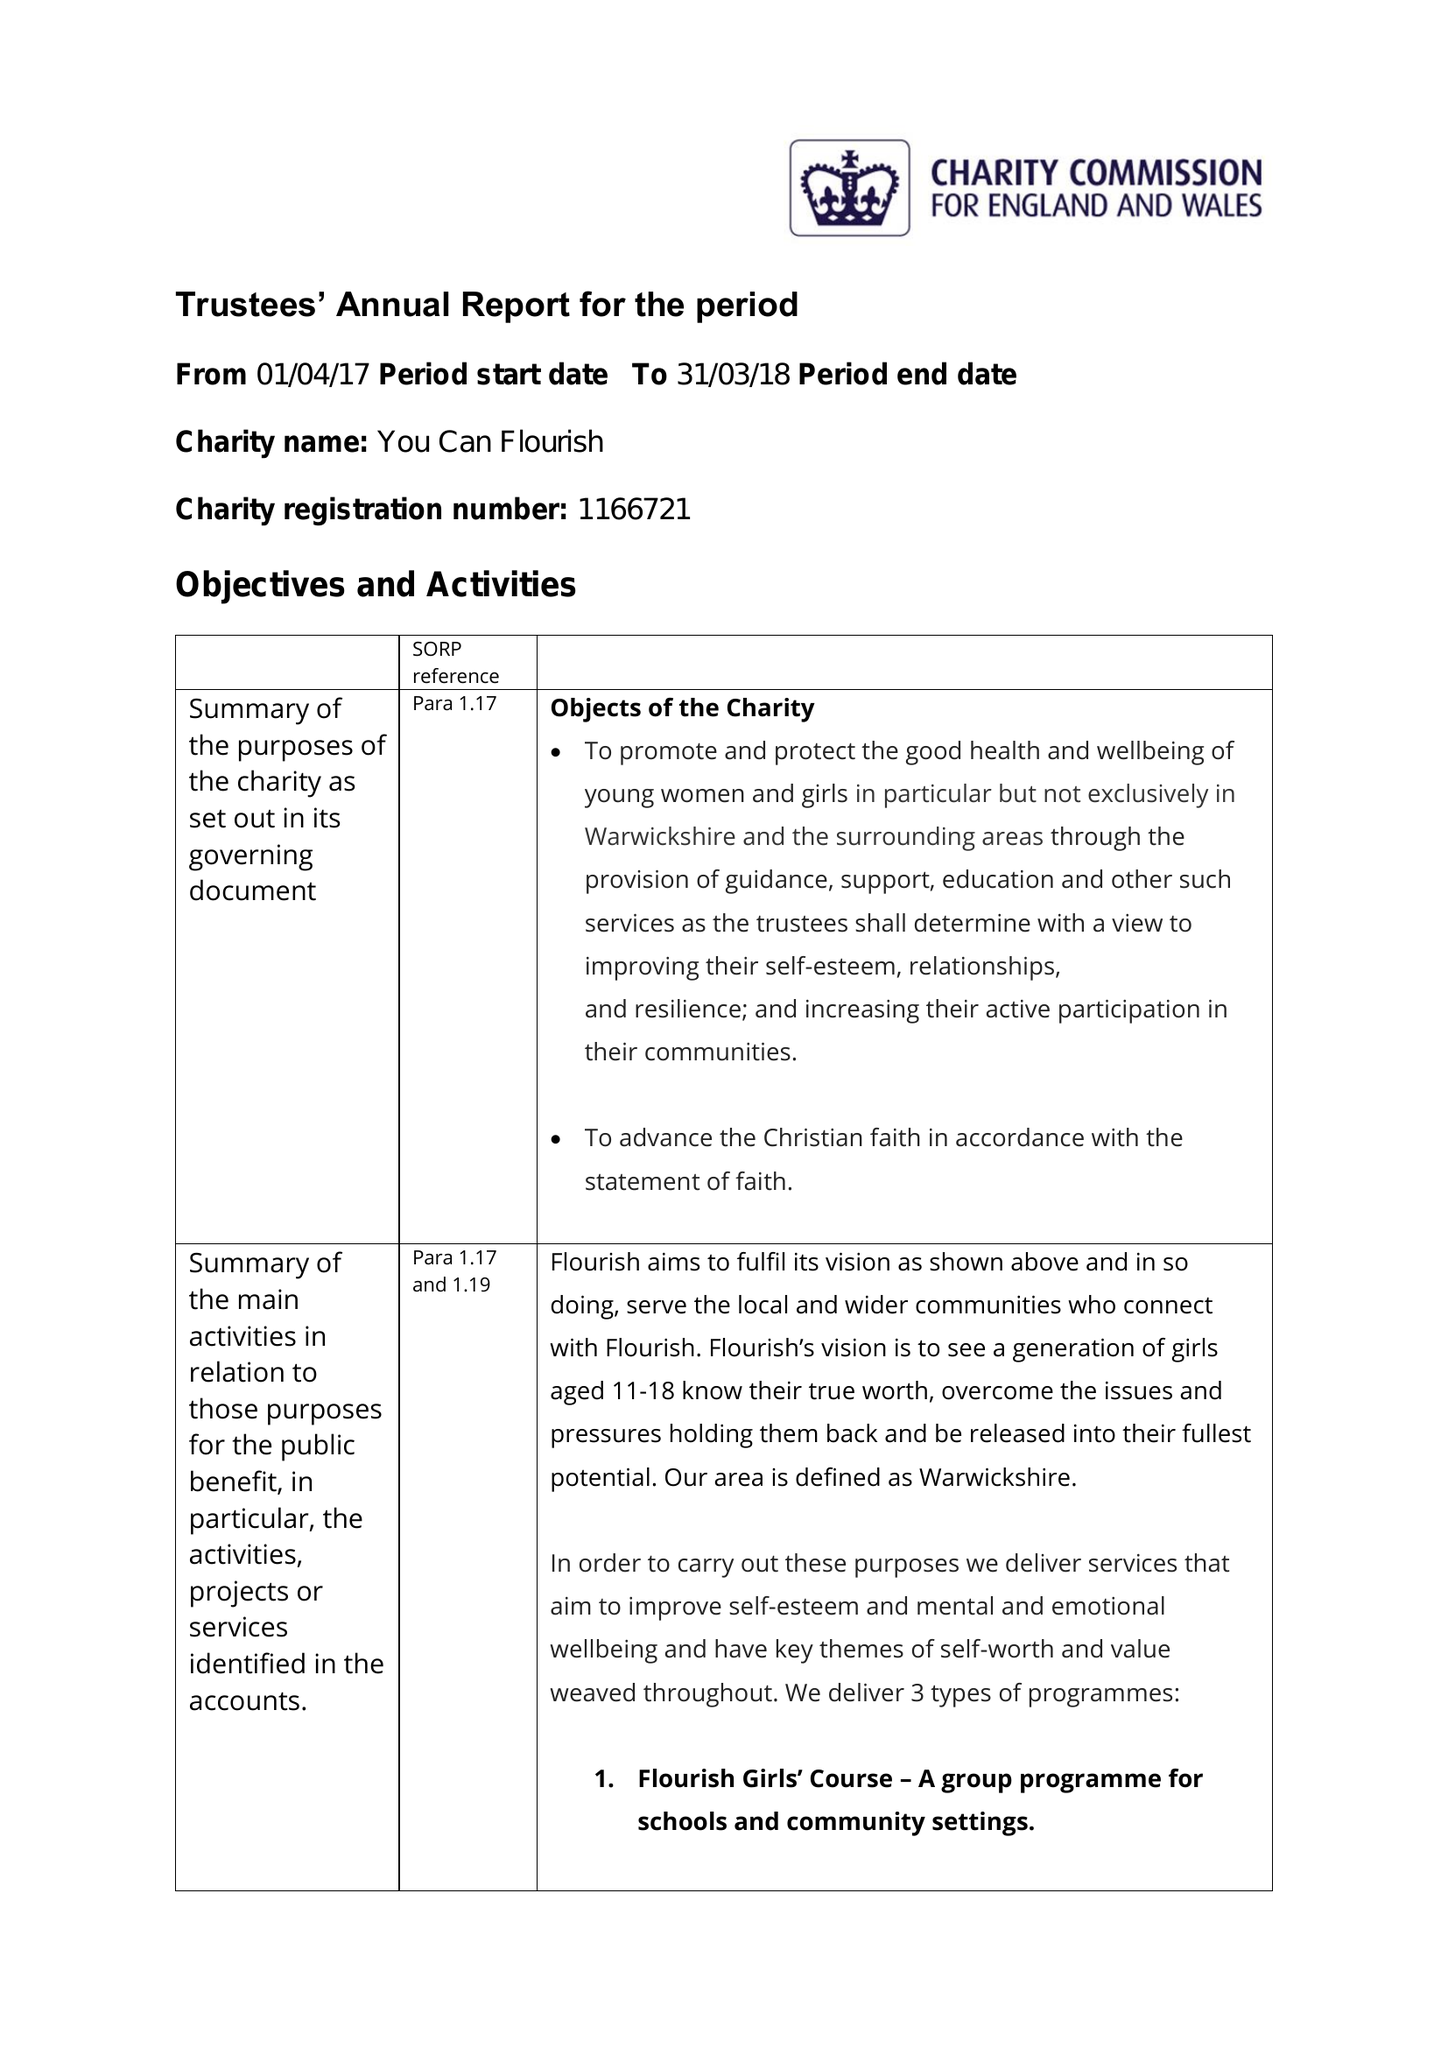What is the value for the charity_number?
Answer the question using a single word or phrase. 1166721 